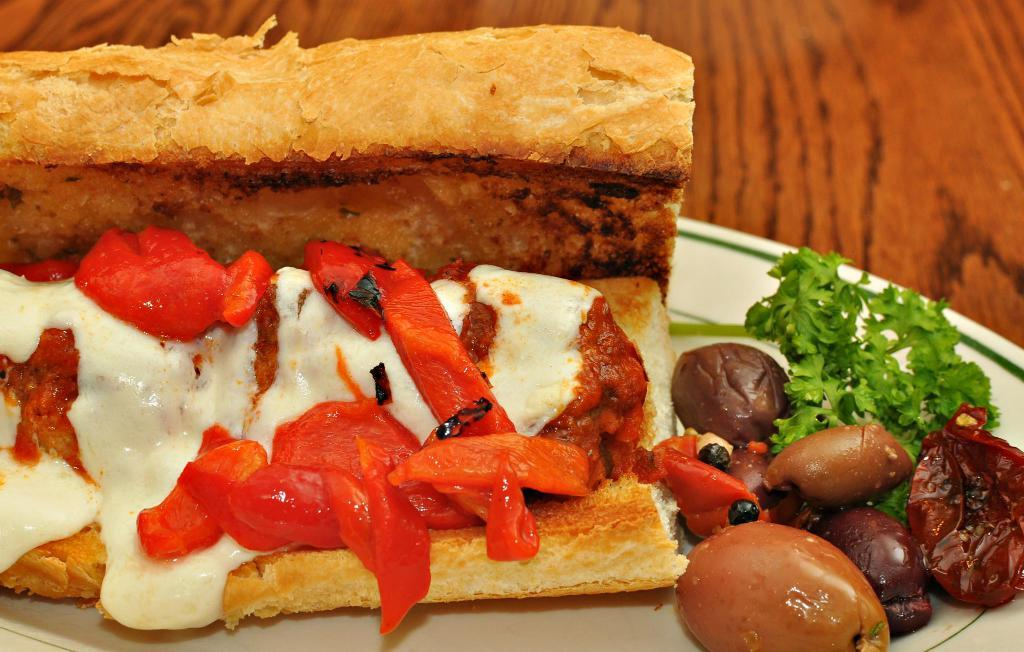What is on the plate in the image? There are food items on a plate in the image. What else is on the plate besides the food items? There are leaves on the plate. Where is the plate located in the image? The plate is placed on a wooden platform. What type of cakes are being served on the voyage in the image? There is no mention of cakes or a voyage in the image; it only shows a plate with food items and leaves on a wooden platform. 